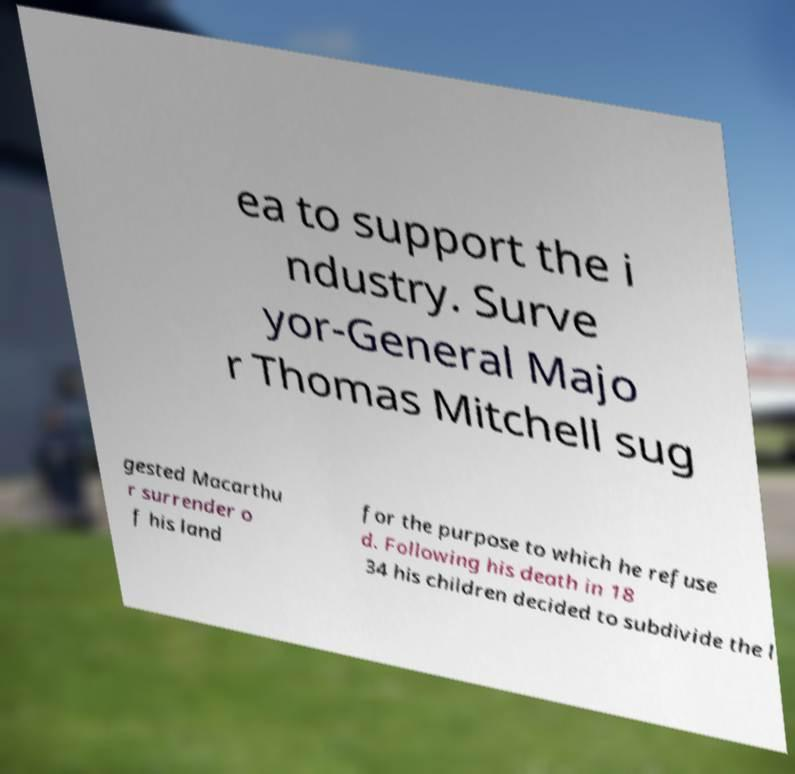Could you extract and type out the text from this image? ea to support the i ndustry. Surve yor-General Majo r Thomas Mitchell sug gested Macarthu r surrender o f his land for the purpose to which he refuse d. Following his death in 18 34 his children decided to subdivide the l 